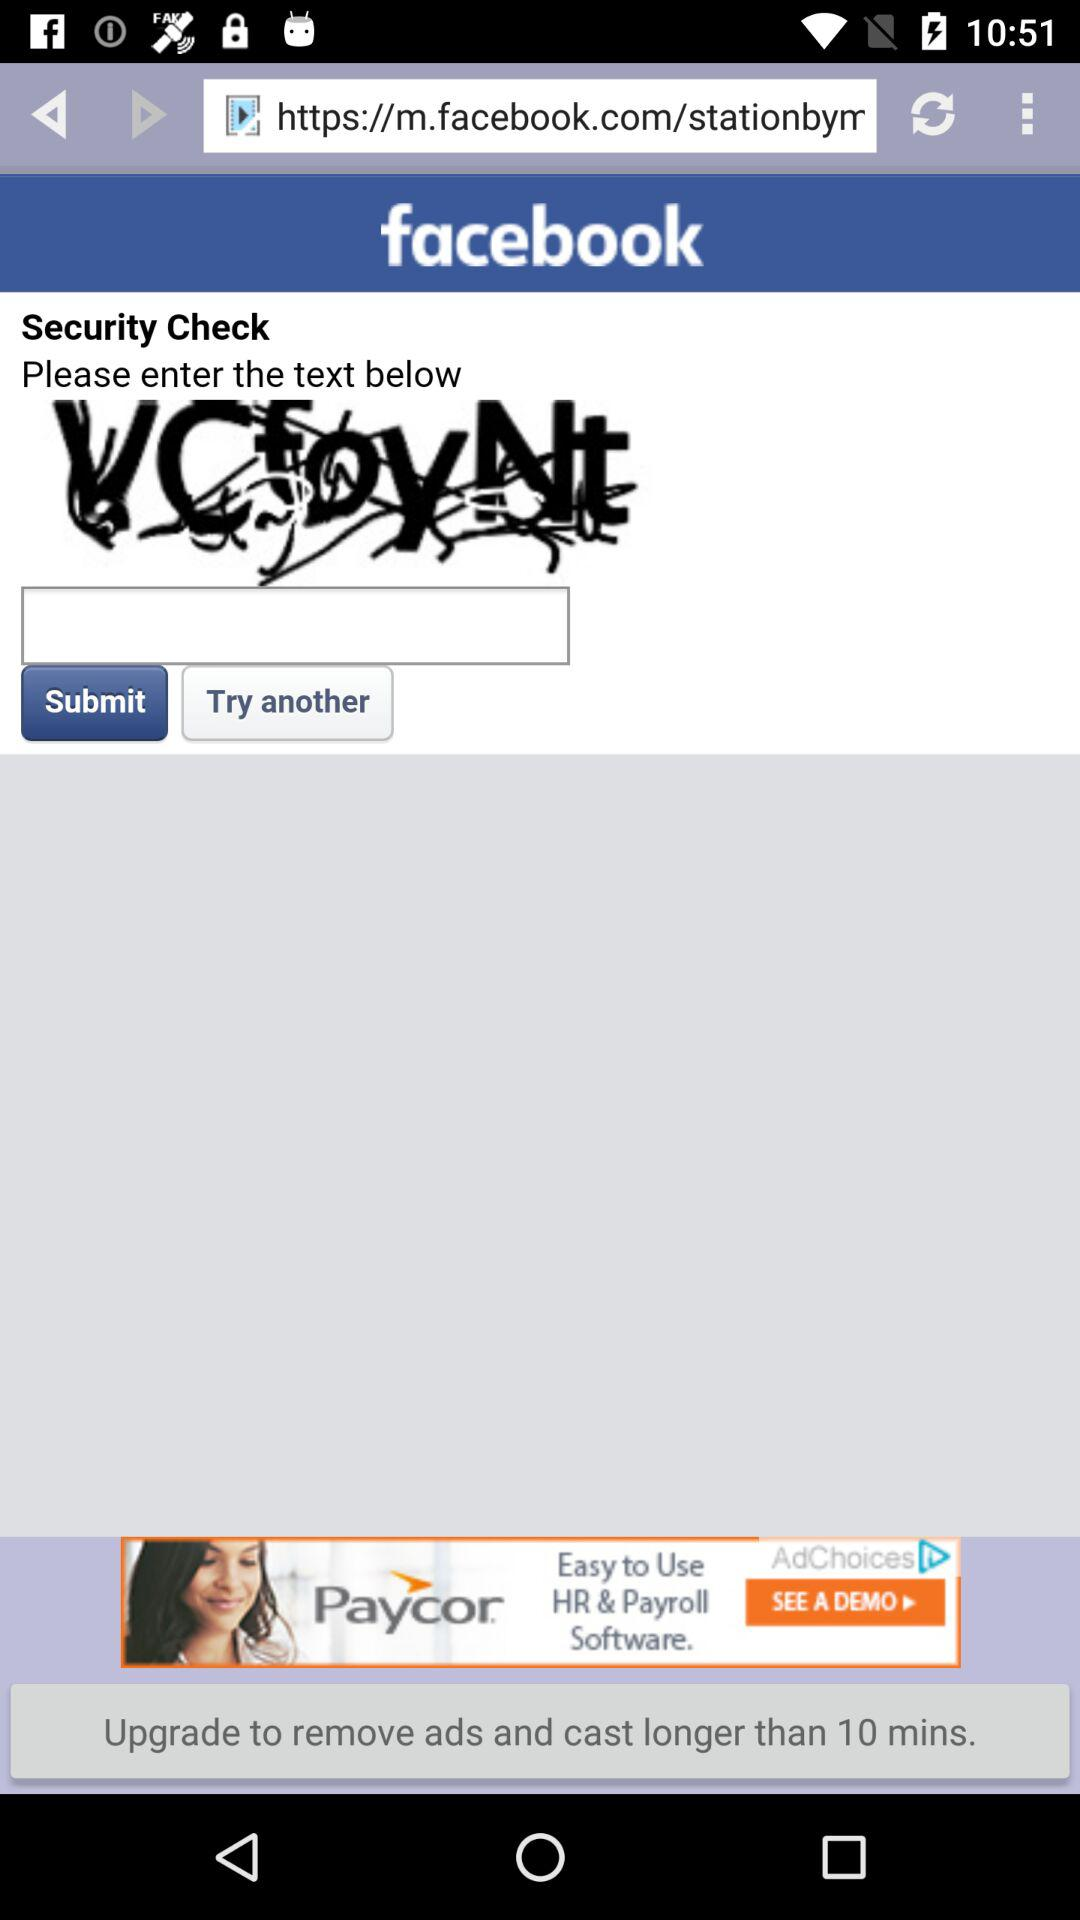What is the security check code? The security check code is "VCfoyNt". 